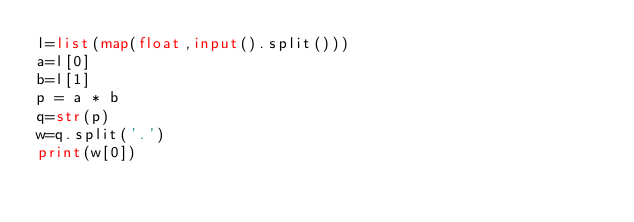Convert code to text. <code><loc_0><loc_0><loc_500><loc_500><_Python_>l=list(map(float,input().split()))
a=l[0]
b=l[1]
p = a * b
q=str(p)
w=q.split('.')
print(w[0])


</code> 